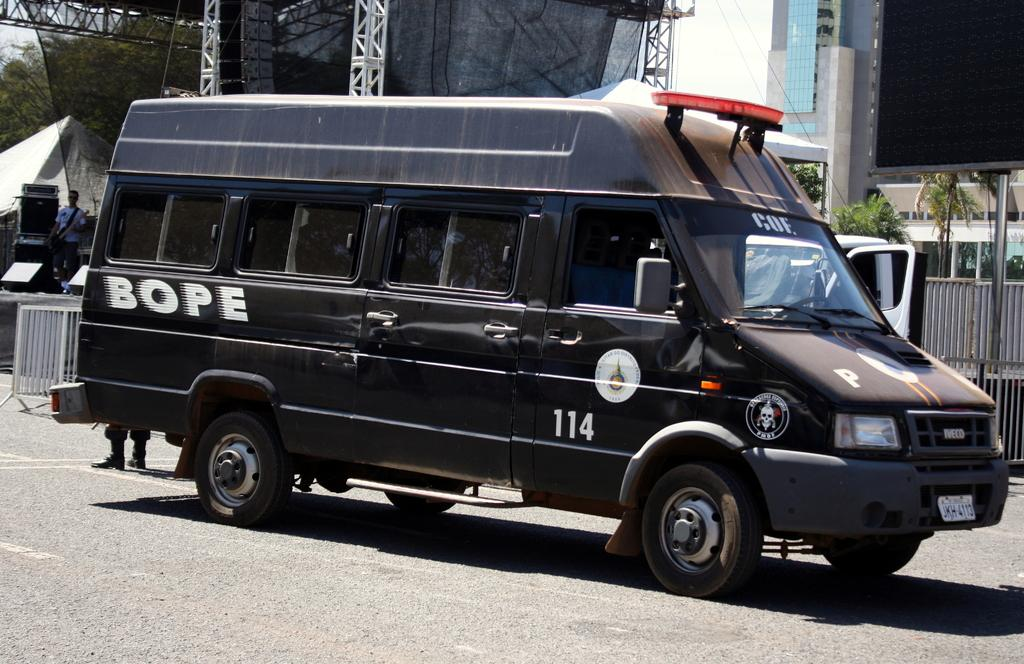<image>
Relay a brief, clear account of the picture shown. the black van parked in a road with the writings of BOPE in it 